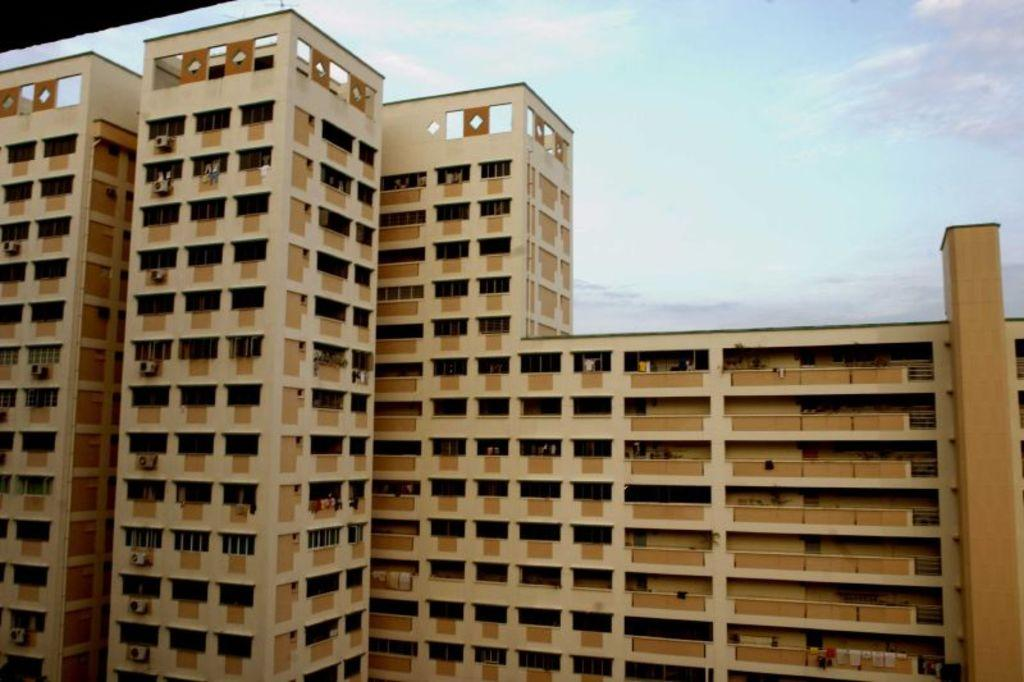What type of structure is present in the image? There is a building in the image. What is the color of the building? The building is brown in color. What can be seen in the sky in the image? There are clouds visible in the image. What is the color of the sky in the image? The sky is blue in the image. Can you hear the army marching in the image? There is no army or sound present in the image, as it is a still image of a building with clouds and a blue sky. 